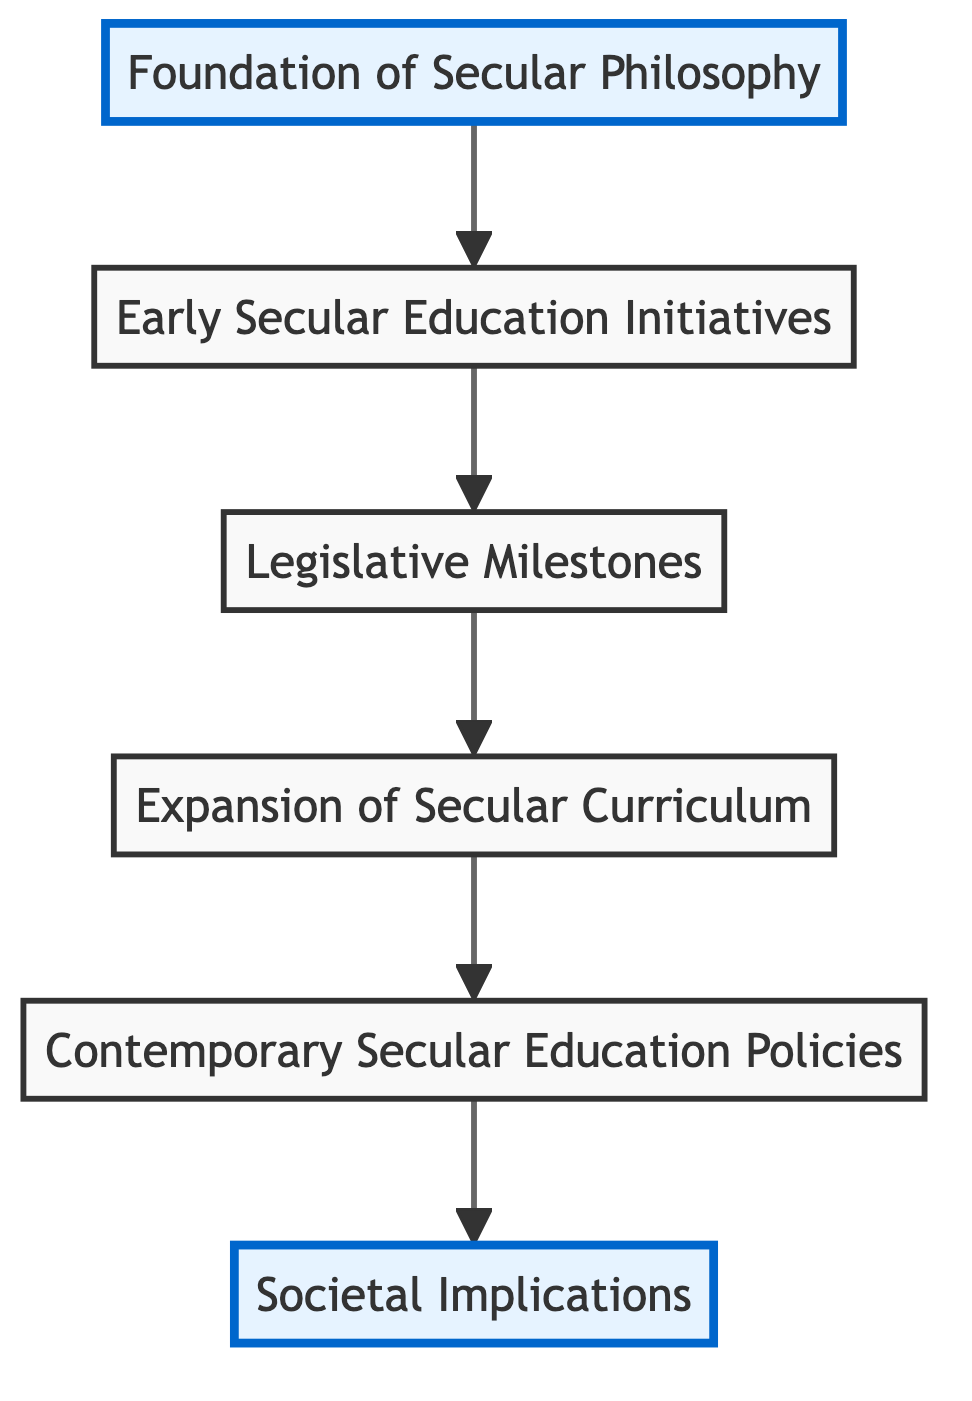What is the first stage in the development of secular education systems? The first stage in the flow chart is "Foundation of Secular Philosophy," which is the starting point of the process outlined in the diagram.
Answer: Foundation of Secular Philosophy How many total stages are depicted in the diagram? By counting the number of distinct nodes in the flow chart, we find there are six stages listed.
Answer: 6 What is emphasized in the "Expansion of Secular Curriculum" stage? The content of this node indicates that there is an introduction of science, philosophy, and critical thinking courses, which reduces the religious content in the curriculum.
Answer: Science, philosophy, critical thinking courses Which stage follows the "Legislative Milestones"? The next stage following "Legislative Milestones" is "Expansion of Secular Curriculum," indicating a progression of the educational system through legislation to curriculum development.
Answer: Expansion of Secular Curriculum What societal outcome is highlighted in the "Societal Implications" stage? The flow chart suggests that increased individual autonomy and critical thinking are societal outcomes resulting from the development of secular education systems.
Answer: Increased individual autonomy and critical thinking How does "Contemporary Secular Education Policies" relate to earlier stages? This stage builds on previous stages by focusing on modern policies in countries emphasizing education without religious bias, continuing the trend initiated in earlier stages.
Answer: Builds on previous stages What type of education does the "Contemporary Secular Education Policies" stage focus on? The content of this node specifies that it emphasizes inclusive and neutral education systems with a focus on ethical and civic education.
Answer: Inclusive and neutral education systems Which historical figure is associated with the "Foundation of Secular Philosophy"? The key figures mentioned include John Locke, Voltaire, and John Stuart Mill, highlighting their contributions to the ideas promoting secular philosophy.
Answer: John Locke, Voltaire, John Stuart Mill What key legislation is mentioned in the "Legislative Milestones"? Important legislation includes the U.S. 1875 Blaine Amendment proposals and the 1905 French law that formalizes the commitment to secular education as noted in the content.
Answer: U.S. 1875 Blaine Amendment, 1905 French law What direction does the flow chart progress in terms of the development of education? The flow chart progresses from bottom to top, illustrating the steps of the development of secular education systems logically from foundational ideas to societal implications.
Answer: Bottom to top 